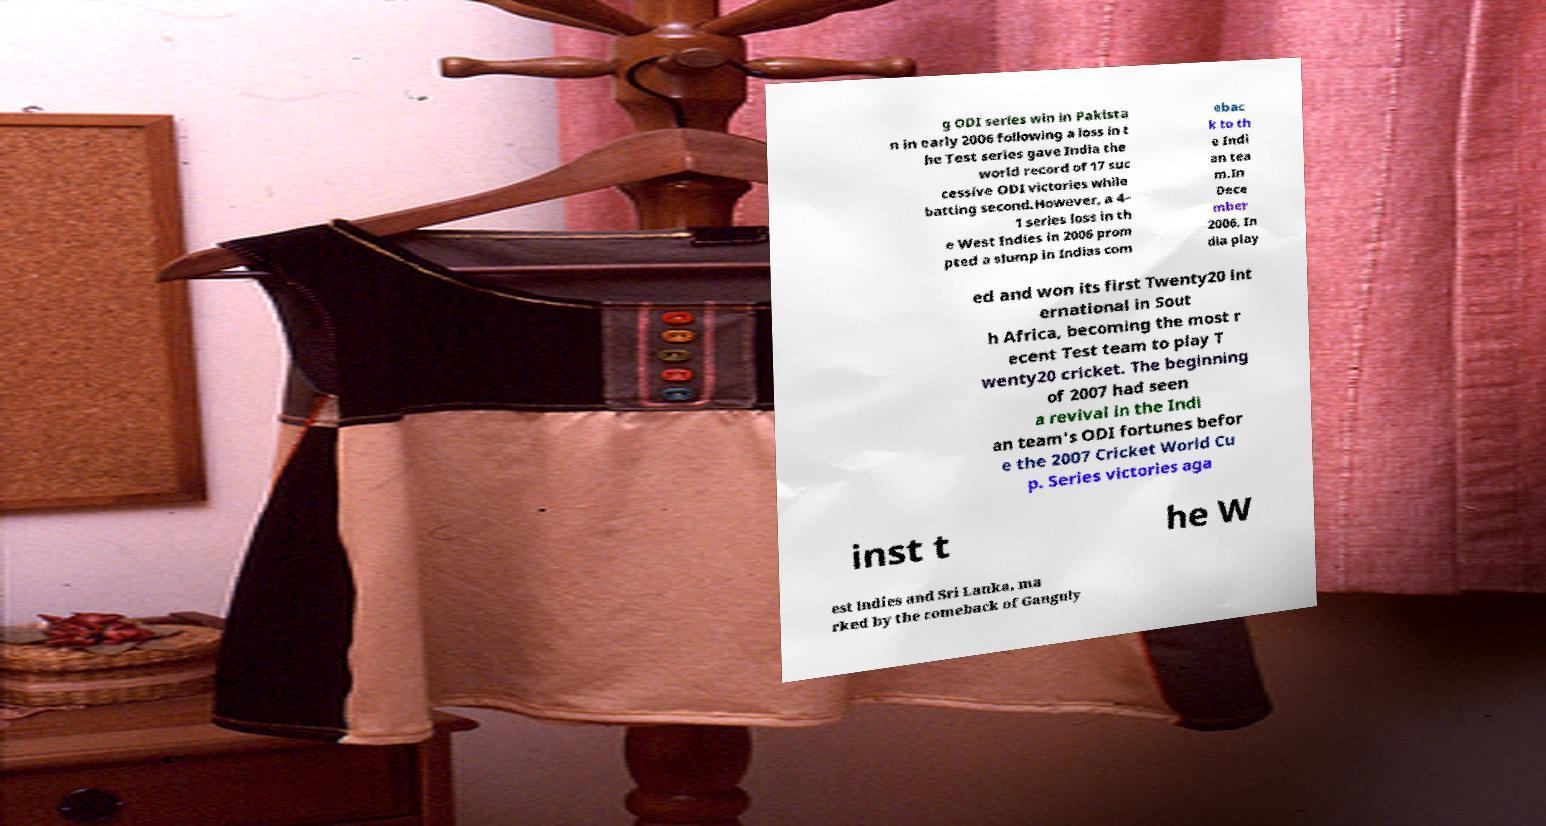Could you assist in decoding the text presented in this image and type it out clearly? g ODI series win in Pakista n in early 2006 following a loss in t he Test series gave India the world record of 17 suc cessive ODI victories while batting second.However, a 4– 1 series loss in th e West Indies in 2006 prom pted a slump in Indias com ebac k to th e Indi an tea m.In Dece mber 2006, In dia play ed and won its first Twenty20 int ernational in Sout h Africa, becoming the most r ecent Test team to play T wenty20 cricket. The beginning of 2007 had seen a revival in the Indi an team's ODI fortunes befor e the 2007 Cricket World Cu p. Series victories aga inst t he W est Indies and Sri Lanka, ma rked by the comeback of Ganguly 